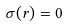Convert formula to latex. <formula><loc_0><loc_0><loc_500><loc_500>\sigma ( r ) = 0</formula> 